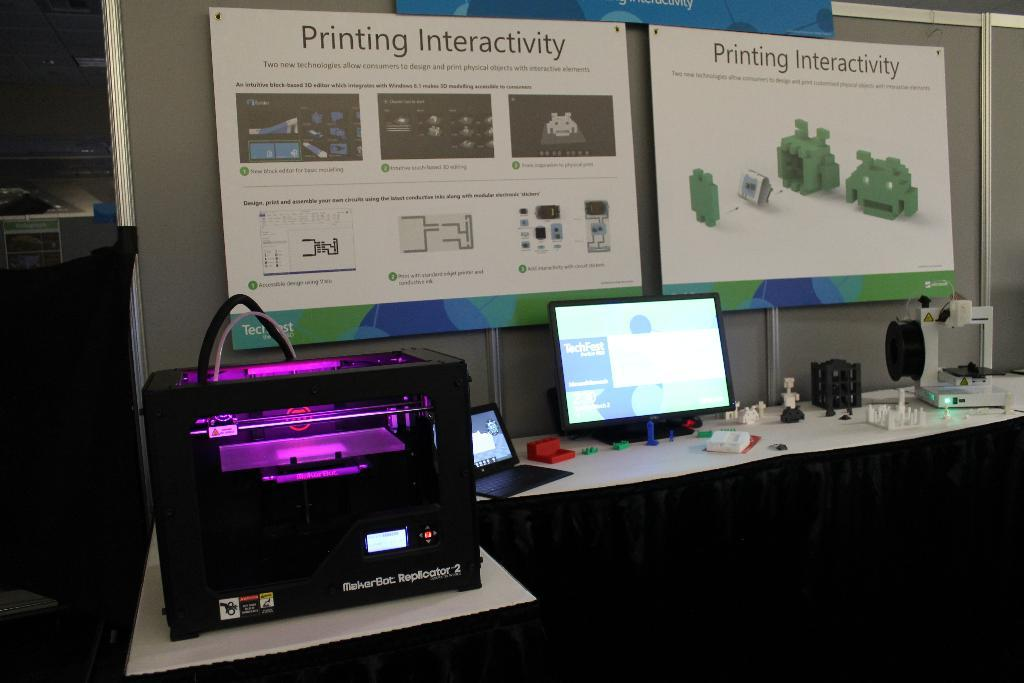<image>
Provide a brief description of the given image. a maker bot replicator 2 is sitting on a table with many other things 